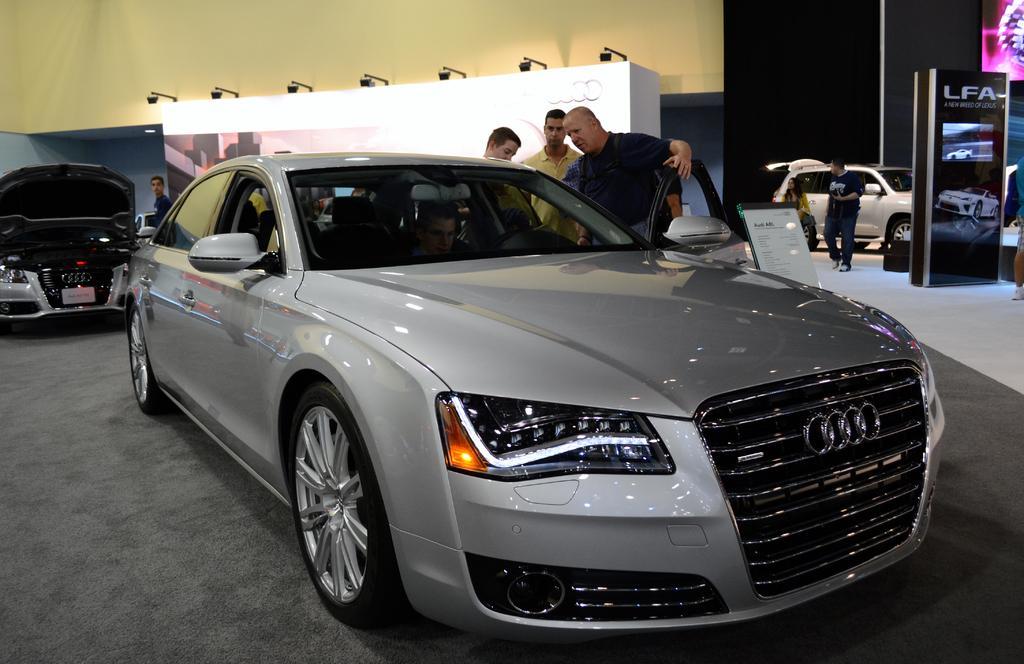In one or two sentences, can you explain what this image depicts? In this picture we can see a car one door is opened and person is holding that door and inside this car one man is sitting and aside to this we have other two men and some other car and in background we can see wall, lights, banner. 